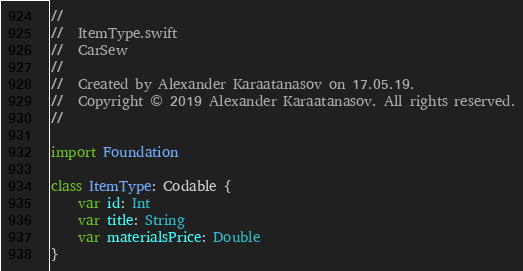Convert code to text. <code><loc_0><loc_0><loc_500><loc_500><_Swift_>//
//  ItemType.swift
//  CarSew
//
//  Created by Alexander Karaatanasov on 17.05.19.
//  Copyright © 2019 Alexander Karaatanasov. All rights reserved.
//

import Foundation

class ItemType: Codable {
    var id: Int
    var title: String
    var materialsPrice: Double
}
</code> 